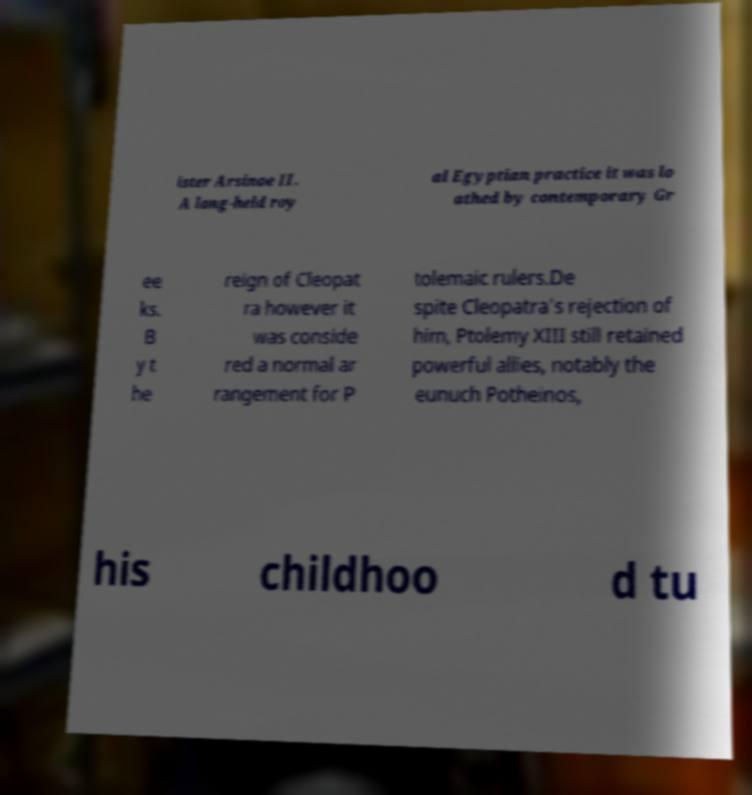Could you assist in decoding the text presented in this image and type it out clearly? ister Arsinoe II. A long-held roy al Egyptian practice it was lo athed by contemporary Gr ee ks. B y t he reign of Cleopat ra however it was conside red a normal ar rangement for P tolemaic rulers.De spite Cleopatra's rejection of him, Ptolemy XIII still retained powerful allies, notably the eunuch Potheinos, his childhoo d tu 